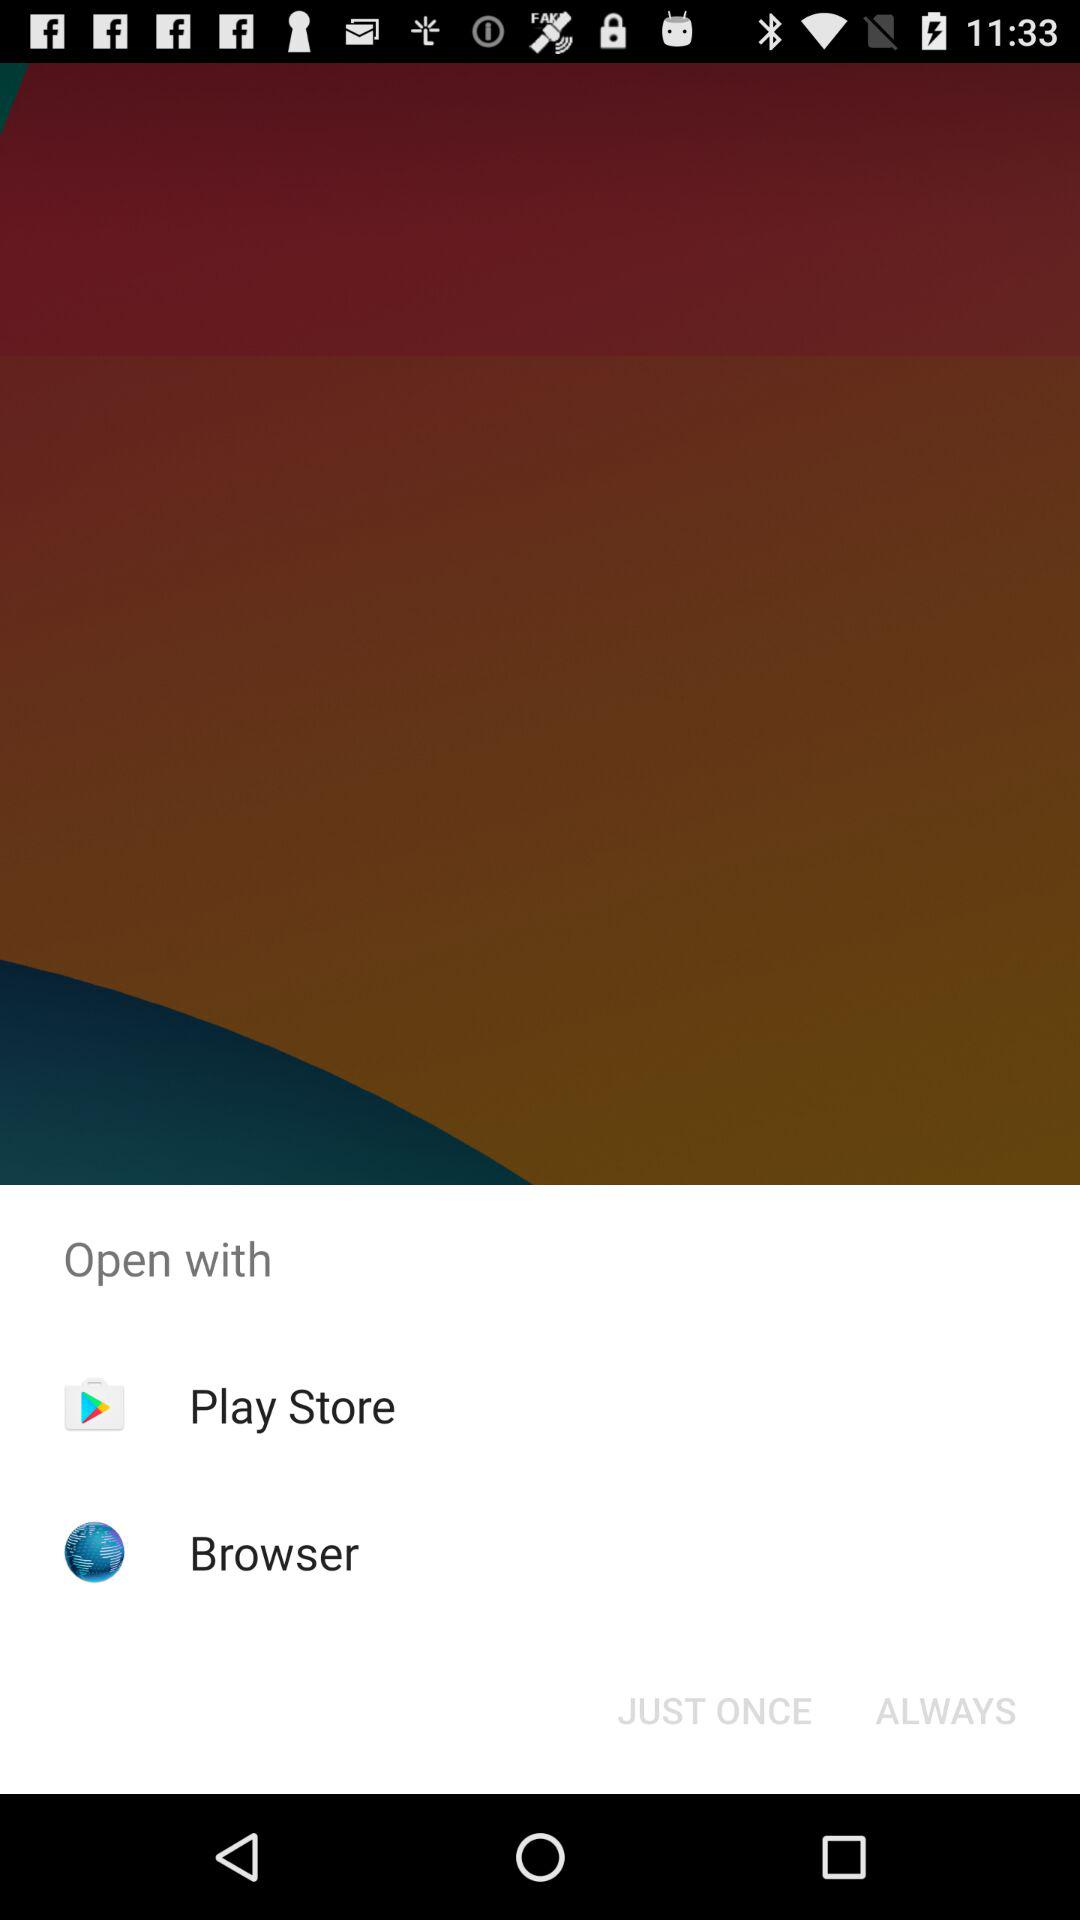Through which application can it be opened? It can be opened through "Play Store" and "Browser". 